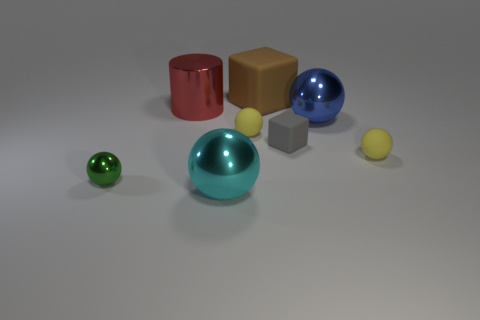There is a sphere right of the shiny ball to the right of the brown matte block; what color is it?
Ensure brevity in your answer.  Yellow. There is a green shiny thing that is in front of the tiny gray object; does it have the same shape as the cyan shiny object?
Your answer should be very brief. Yes. How many spheres are both on the right side of the big cube and in front of the small shiny ball?
Make the answer very short. 0. The matte ball that is to the left of the cube that is behind the metal thing behind the blue metal sphere is what color?
Make the answer very short. Yellow. There is a metal object that is in front of the tiny shiny object; what number of brown blocks are behind it?
Your answer should be compact. 1. How many other objects are there of the same shape as the brown thing?
Your response must be concise. 1. How many things are large blue balls or big objects that are to the left of the large matte thing?
Your answer should be very brief. 3. Are there more small blocks behind the tiny green thing than green spheres that are behind the large brown thing?
Your response must be concise. Yes. There is a gray rubber object to the left of the tiny yellow matte thing right of the shiny thing that is on the right side of the brown block; what is its shape?
Your answer should be compact. Cube. What shape is the large brown matte object behind the sphere on the left side of the red metallic object?
Your response must be concise. Cube. 